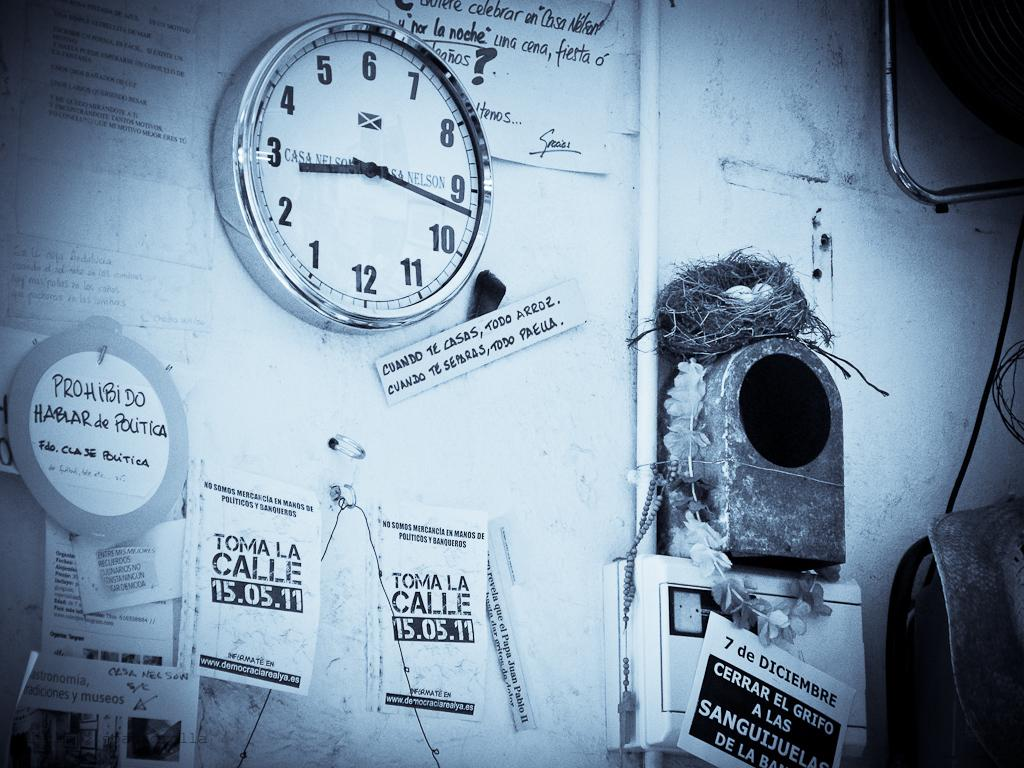What is the main structure in the center of the image? There is a wall in the center of the image. What type of object can be seen in the image? There is a watch in the image. What decorative items are present in the image? There are posters in the image. What can be found in the image that is related to birds? There is a nest in the image. How many objects are attached to the wall in the image? There are many objects on the wall in the image. Where is the fireman stationed in the image? There is no fireman present in the image. What type of land can be seen in the image? The image does not depict any land; it primarily features a wall with various objects and items. 